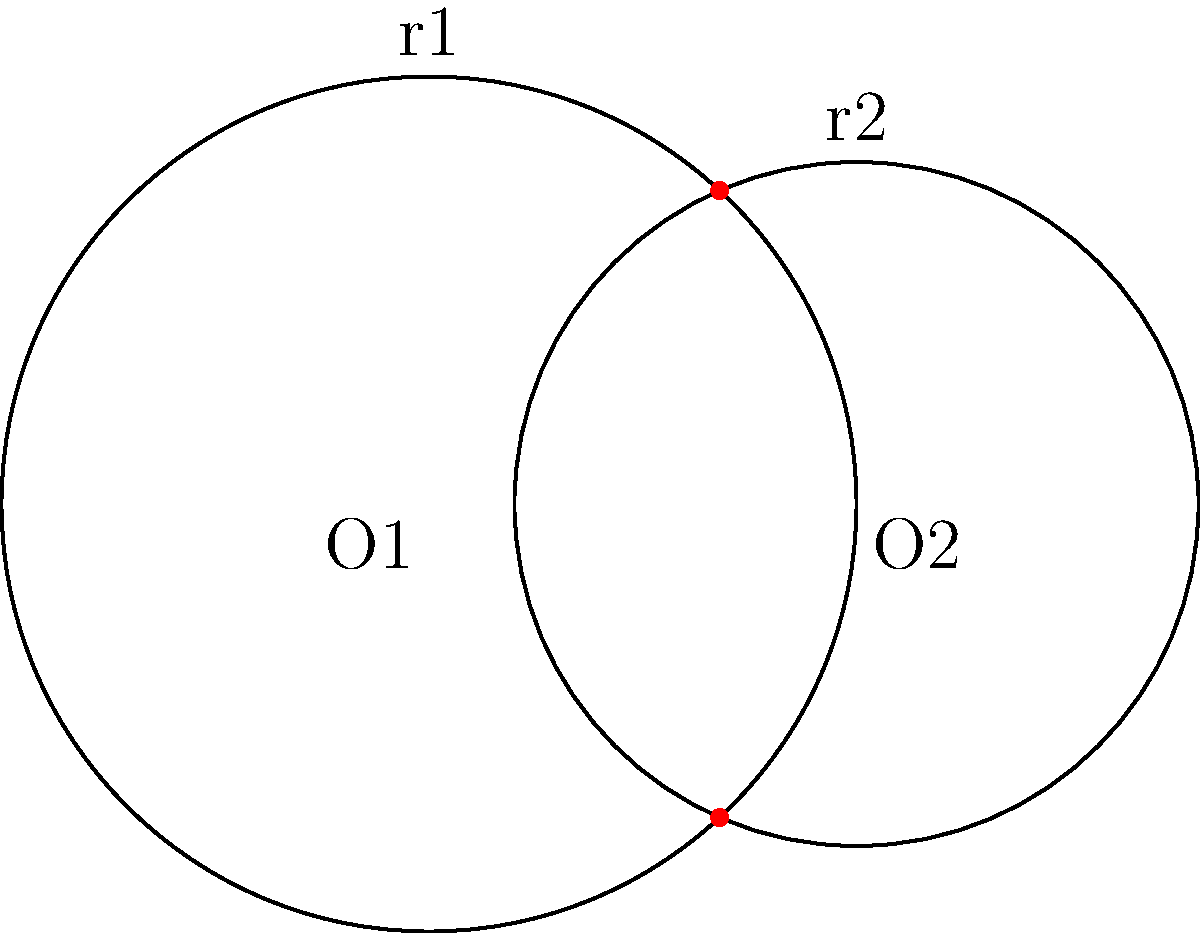In a Kubernetes cluster deployment diagram, two overlapping service areas are represented by intersecting circles. The circle centered at O1 has a radius r1 = 1 unit, while the circle centered at O2 has a radius r2 = 0.8 units. The distance between the centers O1 and O2 is 1 unit. Calculate the area of the region where the two service areas overlap, representing the shared resources between microservices. To solve this problem, we'll use the formula for the area of intersection between two circles. Let's break it down step-by-step:

1) First, we need to find the distance between the centers of the circles:
   $d = 1$ (given in the problem)

2) We know the radii:
   $r1 = 1$ and $r2 = 0.8$

3) Now, we need to calculate the angles $\theta_1$ and $\theta_2$ using the law of cosines:

   $\cos(\theta_1/2) = \frac{r1^2 + d^2 - r2^2}{2r1d}$
   $\cos(\theta_2/2) = \frac{r2^2 + d^2 - r1^2}{2r2d}$

4) Substituting the values:

   $\cos(\theta_1/2) = \frac{1^2 + 1^2 - 0.8^2}{2(1)(1)} = 0.68$
   $\theta_1 = 2 \arccos(0.68) = 1.742$ radians

   $\cos(\theta_2/2) = \frac{0.8^2 + 1^2 - 1^2}{2(0.8)(1)} = 0.25$
   $\theta_2 = 2 \arccos(0.25) = 2.498$ radians

5) The area of intersection is given by:

   $A = r1^2(\theta_1 - \sin(\theta_1))/2 + r2^2(\theta_2 - \sin(\theta_2))/2$

6) Substituting the values:

   $A = 1^2(1.742 - \sin(1.742))/2 + 0.8^2(2.498 - \sin(2.498))/2$
   $A = (1.742 - 0.9856)/2 + 0.64(2.498 - 0.5991)/2$
   $A = 0.3782 + 0.6075 = 0.9857$

Therefore, the area of the overlapping region is approximately 0.9857 square units.
Answer: 0.9857 square units 